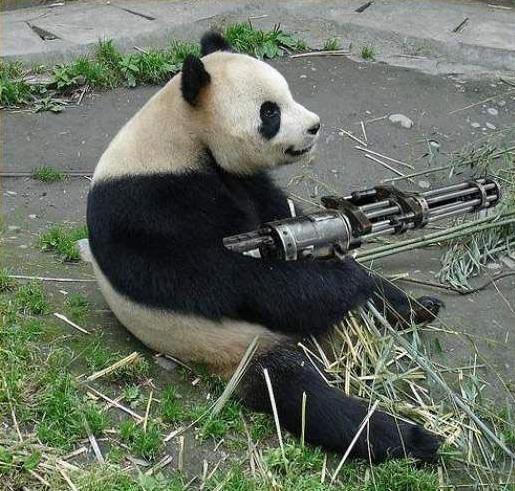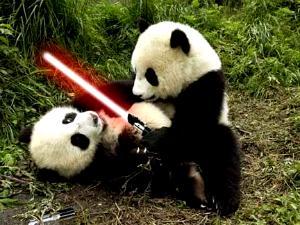The first image is the image on the left, the second image is the image on the right. Analyze the images presented: Is the assertion "there are two pandas in front of a tree trunk" valid? Answer yes or no. No. 